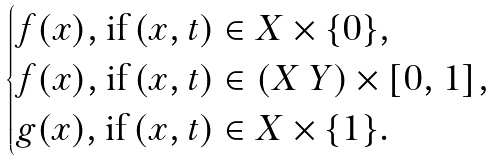<formula> <loc_0><loc_0><loc_500><loc_500>\begin{cases} f ( x ) , \text {if} \, ( x , t ) \in X \times \{ 0 \} , \\ f ( x ) , \text {if} \, ( x , t ) \in \left ( X \ Y \right ) \times [ 0 , 1 ] , \\ g ( x ) , \text {if} \, ( x , t ) \in X \times \{ 1 \} . \\ \end{cases}</formula> 